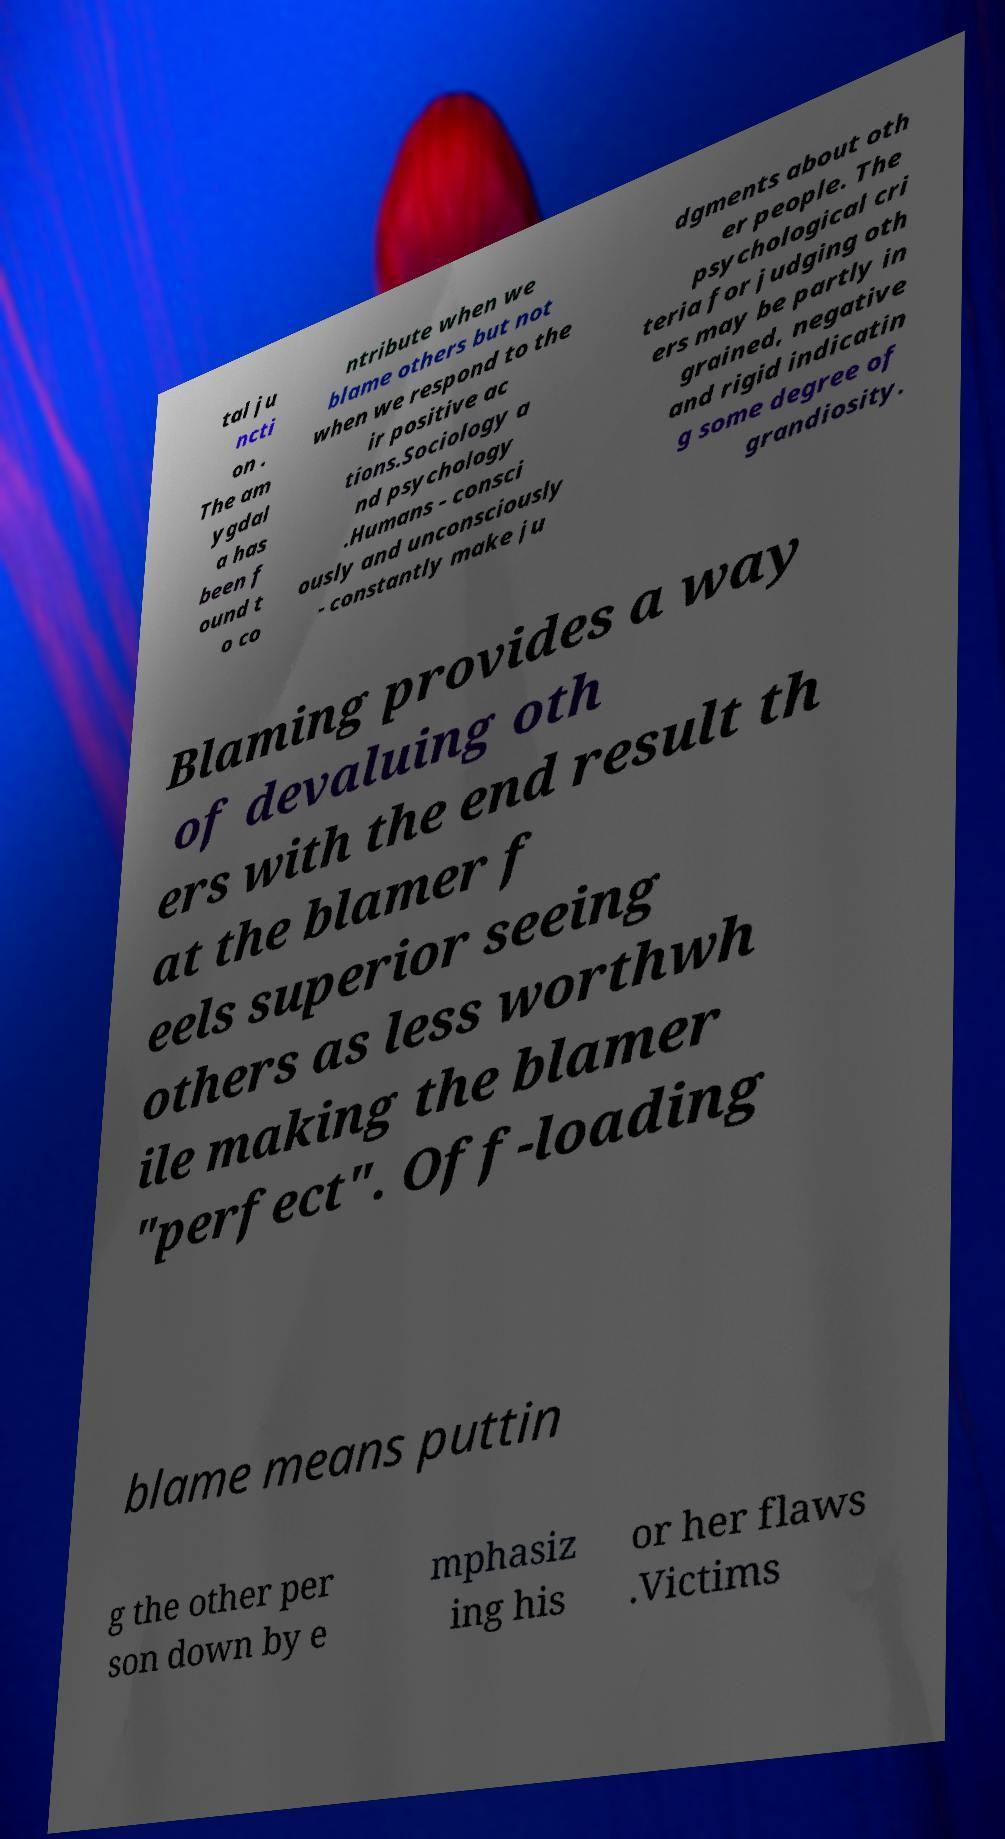Could you extract and type out the text from this image? tal ju ncti on . The am ygdal a has been f ound t o co ntribute when we blame others but not when we respond to the ir positive ac tions.Sociology a nd psychology .Humans - consci ously and unconsciously - constantly make ju dgments about oth er people. The psychological cri teria for judging oth ers may be partly in grained, negative and rigid indicatin g some degree of grandiosity. Blaming provides a way of devaluing oth ers with the end result th at the blamer f eels superior seeing others as less worthwh ile making the blamer "perfect". Off-loading blame means puttin g the other per son down by e mphasiz ing his or her flaws .Victims 